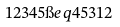<formula> <loc_0><loc_0><loc_500><loc_500>1 2 3 4 5 \i e q 4 5 3 1 2</formula> 